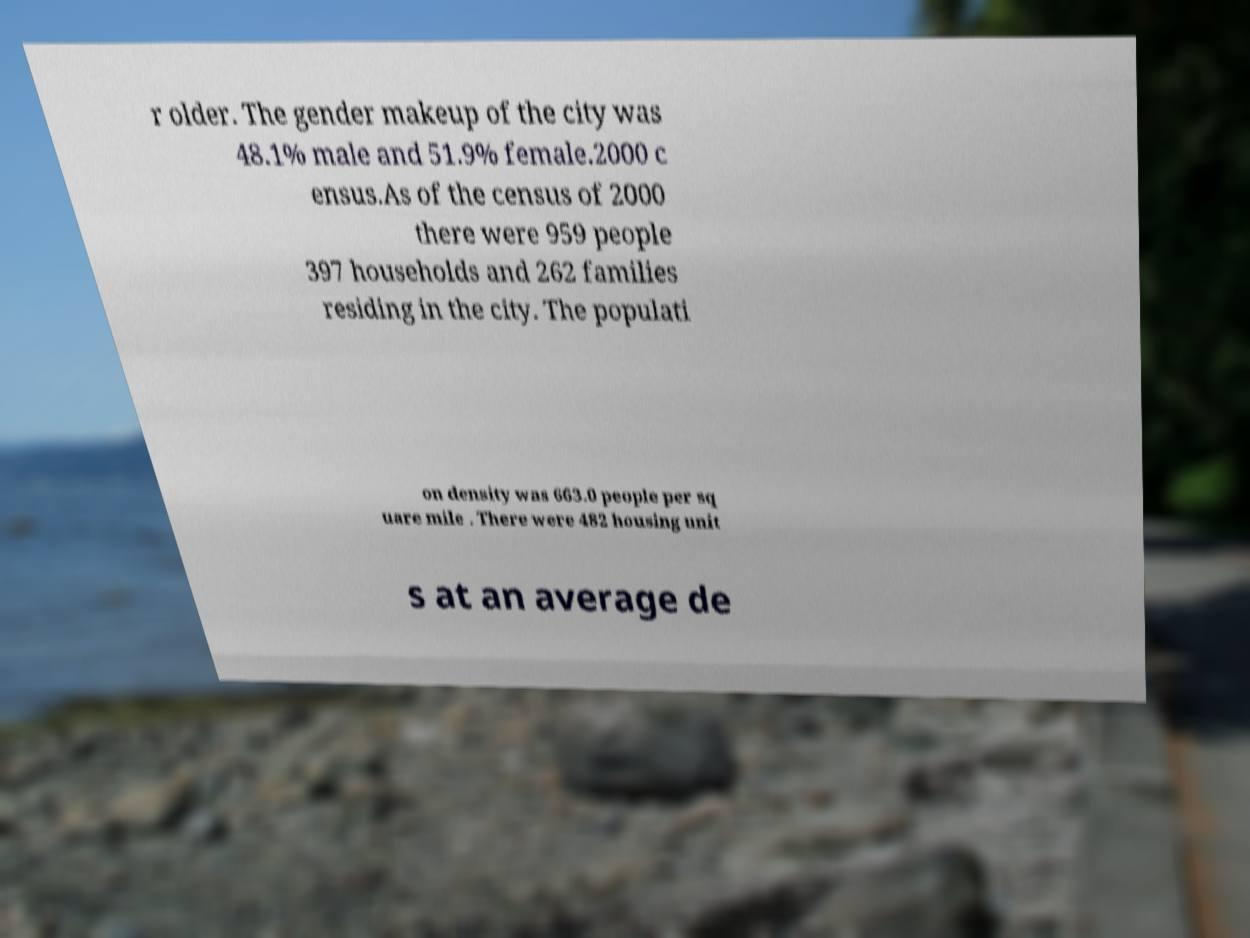Could you extract and type out the text from this image? r older. The gender makeup of the city was 48.1% male and 51.9% female.2000 c ensus.As of the census of 2000 there were 959 people 397 households and 262 families residing in the city. The populati on density was 663.0 people per sq uare mile . There were 482 housing unit s at an average de 